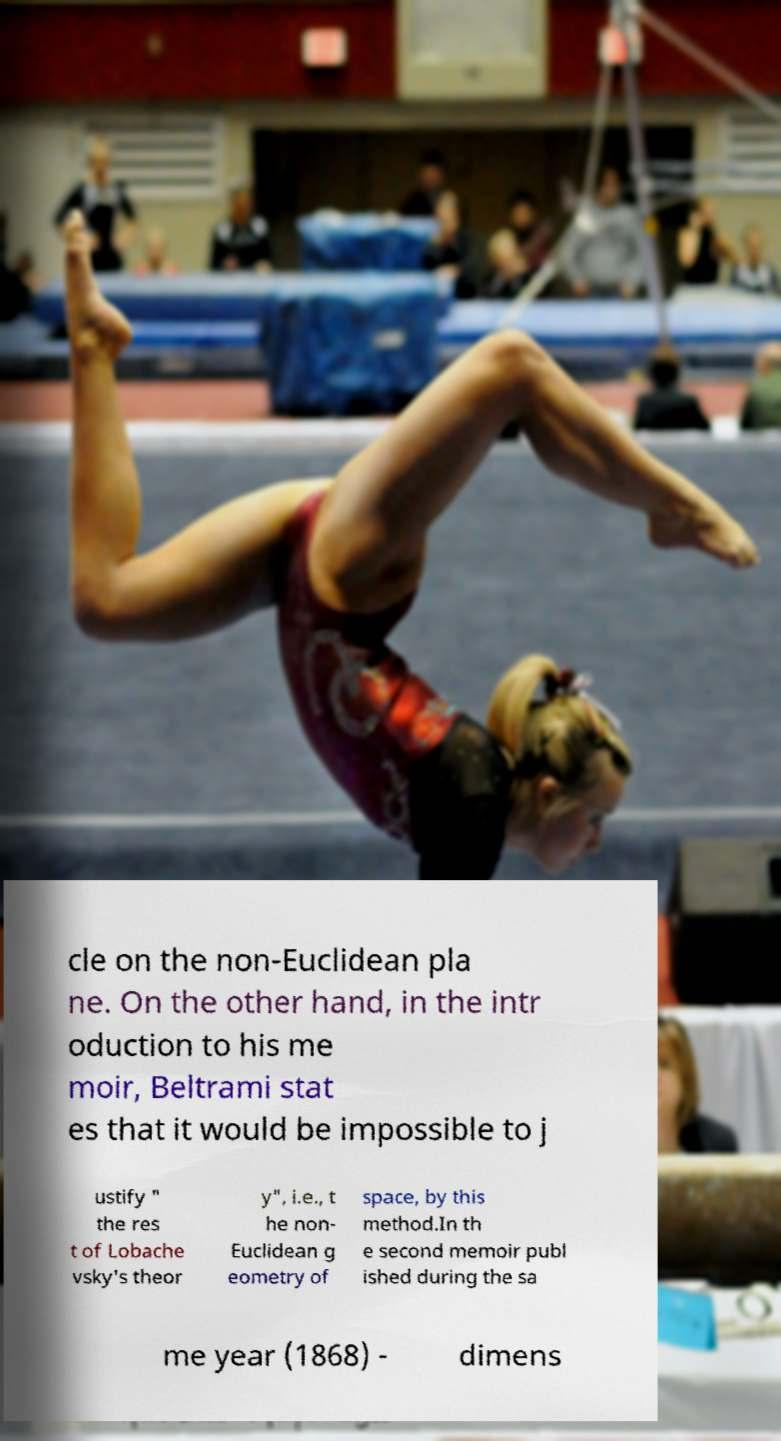For documentation purposes, I need the text within this image transcribed. Could you provide that? cle on the non-Euclidean pla ne. On the other hand, in the intr oduction to his me moir, Beltrami stat es that it would be impossible to j ustify " the res t of Lobache vsky's theor y", i.e., t he non- Euclidean g eometry of space, by this method.In th e second memoir publ ished during the sa me year (1868) - dimens 